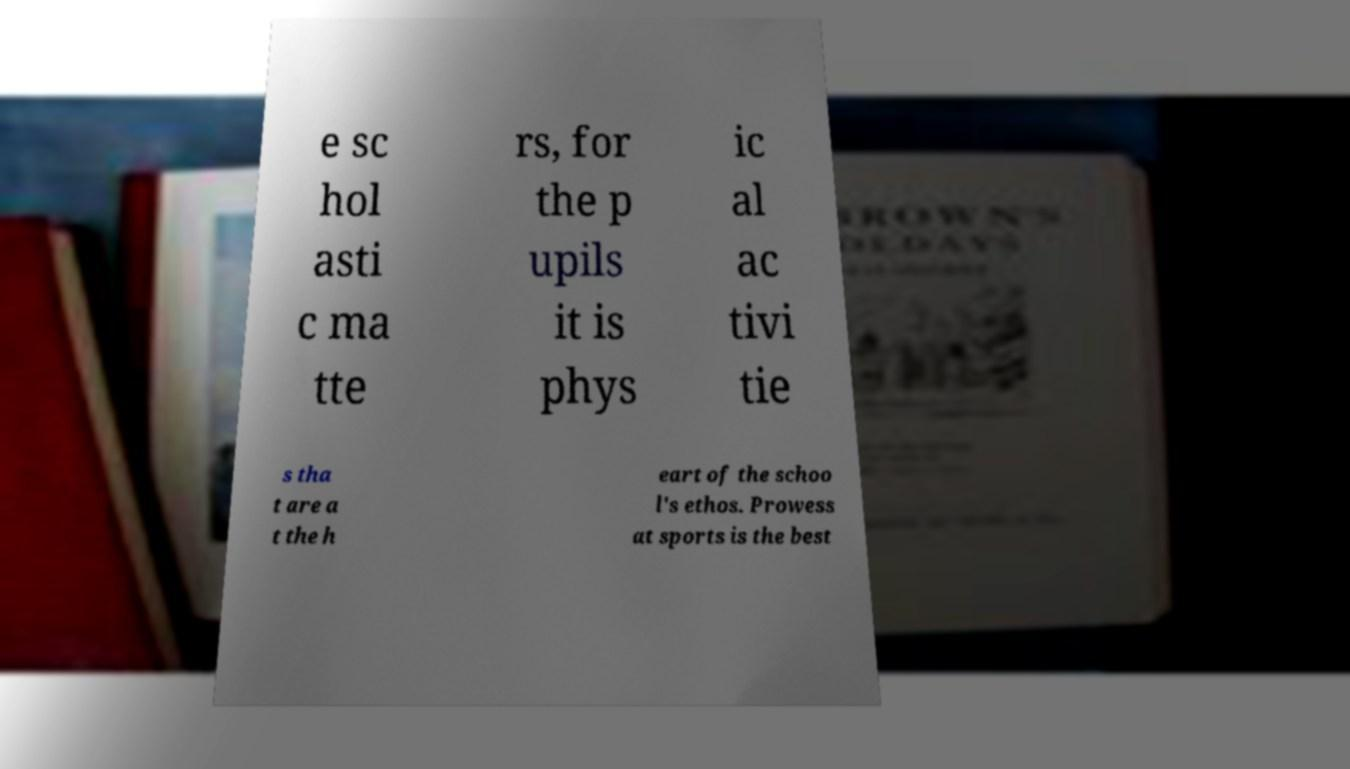What messages or text are displayed in this image? I need them in a readable, typed format. e sc hol asti c ma tte rs, for the p upils it is phys ic al ac tivi tie s tha t are a t the h eart of the schoo l's ethos. Prowess at sports is the best 